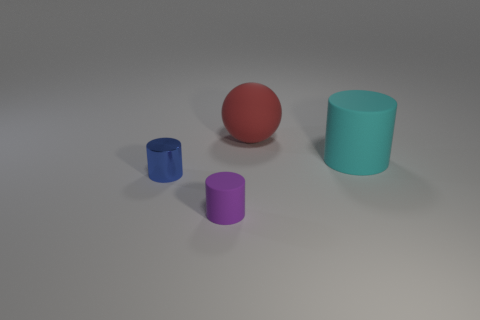Can you describe the colors of the objects? Certainly! There is a red sphere, a blue cylinder, a purple cylinder, and a lighter blue cup or small cylinder.  What could these objects be used for in a real-world setting? These objects could be used for various educational purposes, such as teaching about shapes and colors, or demonstrating the principles of geometry and volume in a math class. In a more creative setting, they could serve as elements in a still life composition for an art project. 